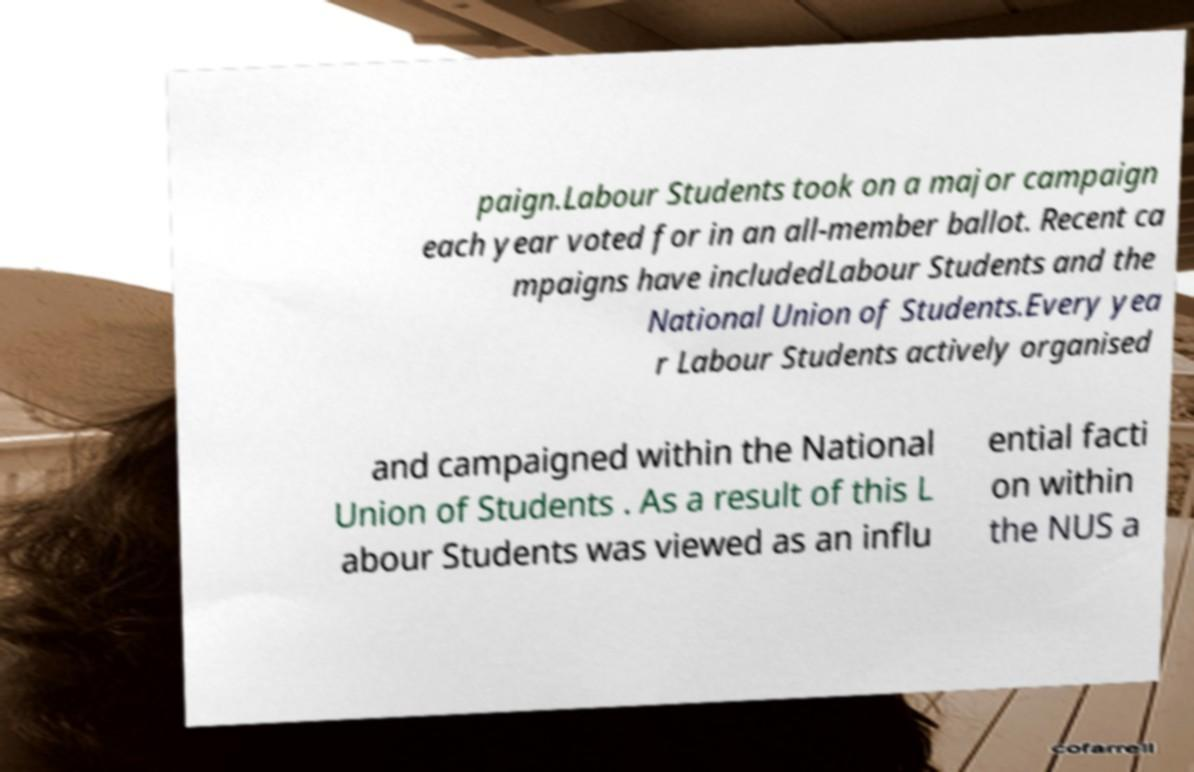Could you extract and type out the text from this image? paign.Labour Students took on a major campaign each year voted for in an all-member ballot. Recent ca mpaigns have includedLabour Students and the National Union of Students.Every yea r Labour Students actively organised and campaigned within the National Union of Students . As a result of this L abour Students was viewed as an influ ential facti on within the NUS a 